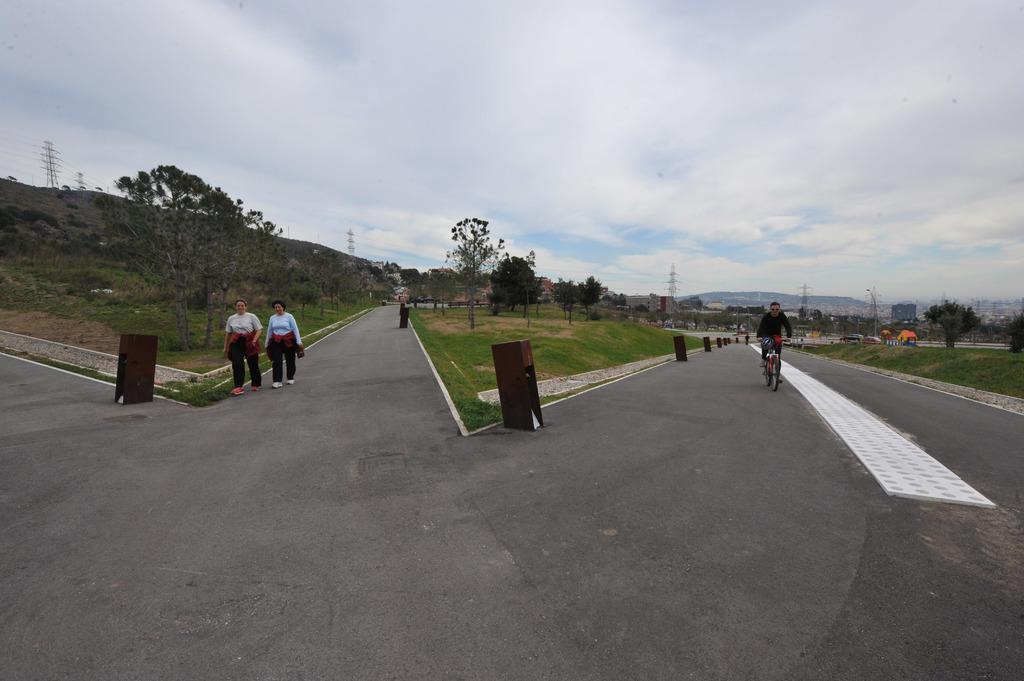Describe this image in one or two sentences. In this image we can see persons, trees, dustbins, road, towers, tents, sky and clouds. 